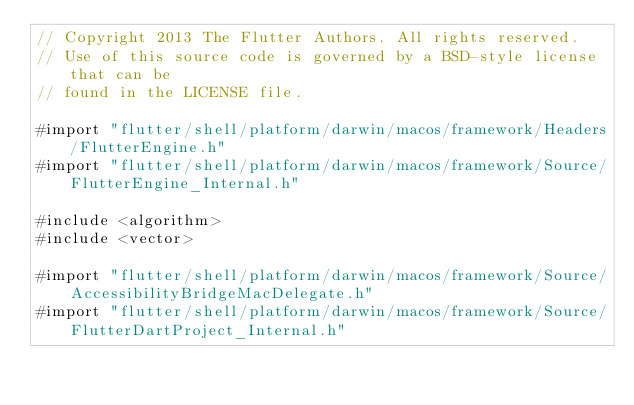Convert code to text. <code><loc_0><loc_0><loc_500><loc_500><_ObjectiveC_>// Copyright 2013 The Flutter Authors. All rights reserved.
// Use of this source code is governed by a BSD-style license that can be
// found in the LICENSE file.

#import "flutter/shell/platform/darwin/macos/framework/Headers/FlutterEngine.h"
#import "flutter/shell/platform/darwin/macos/framework/Source/FlutterEngine_Internal.h"

#include <algorithm>
#include <vector>

#import "flutter/shell/platform/darwin/macos/framework/Source/AccessibilityBridgeMacDelegate.h"
#import "flutter/shell/platform/darwin/macos/framework/Source/FlutterDartProject_Internal.h"</code> 